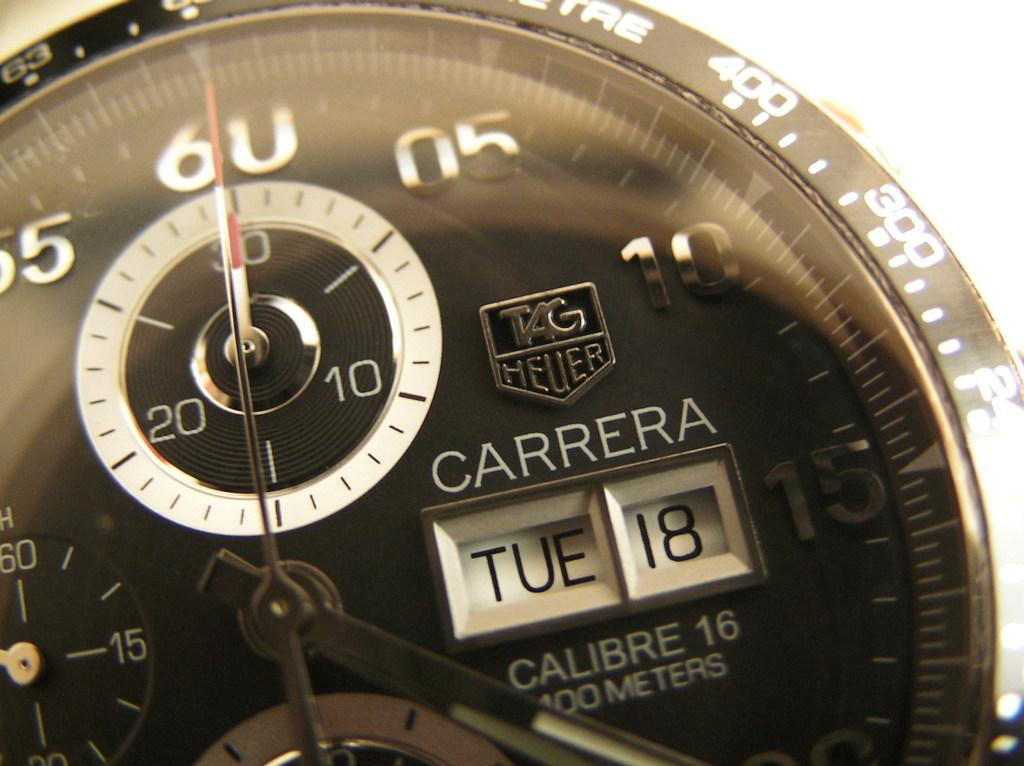Provide a one-sentence caption for the provided image. A Carrera watch displays the day and date of TUE 18. 